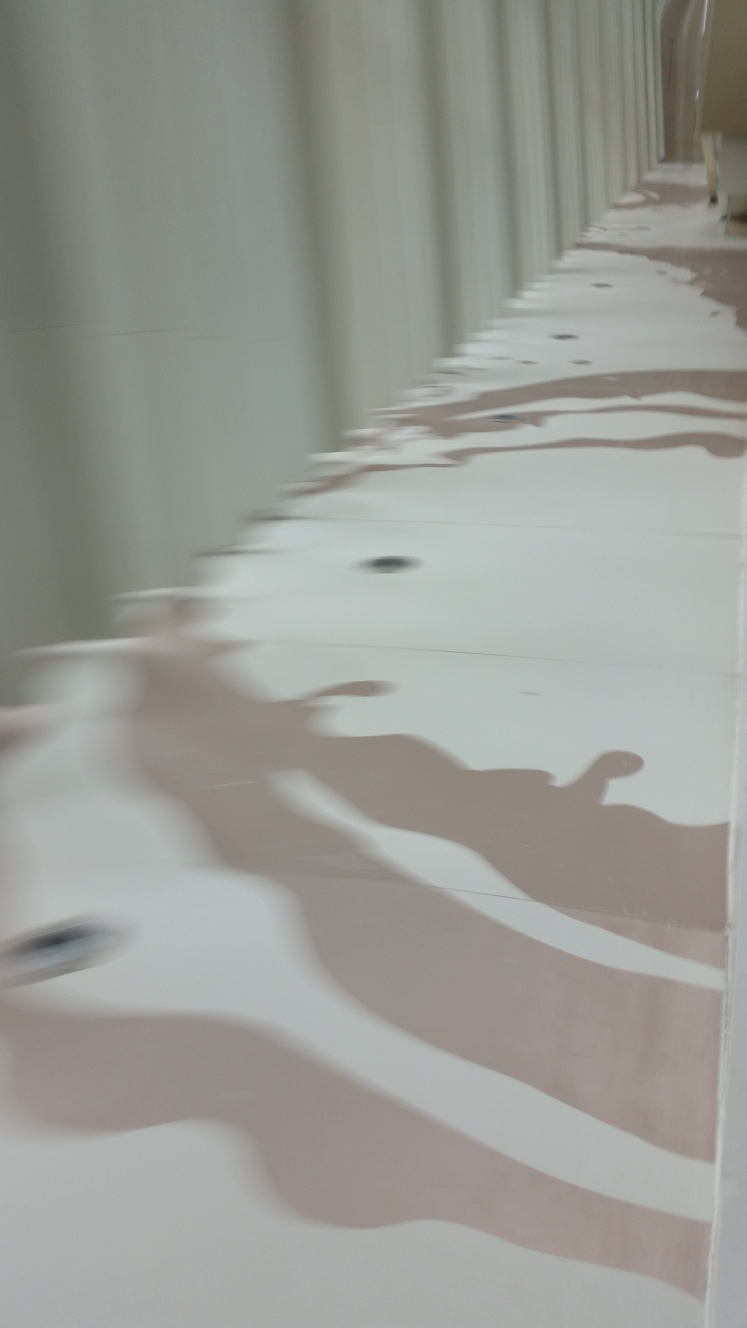What does the pattern of light and shadow on the surface suggest to you? The interplay of light and shadow gives off an almost liquid-like appearance on the surface, creating a dynamic and rhythmic pattern. It could imply a deliberate design choice to evoke water or other natural elements through the use of reflection and light, capturing the viewer's attention and enlivening the space. Could it represent something in the design itself? Yes, it's possible that the designer aimed to infuse the space with organic elements, drawing inspiration from nature. The undulating pattern could symbolize waves or dunes, suggesting a connection with natural landscapes. This might be a part of a larger theme within the building or installation, aiming to create harmony between the built environment and nature. 